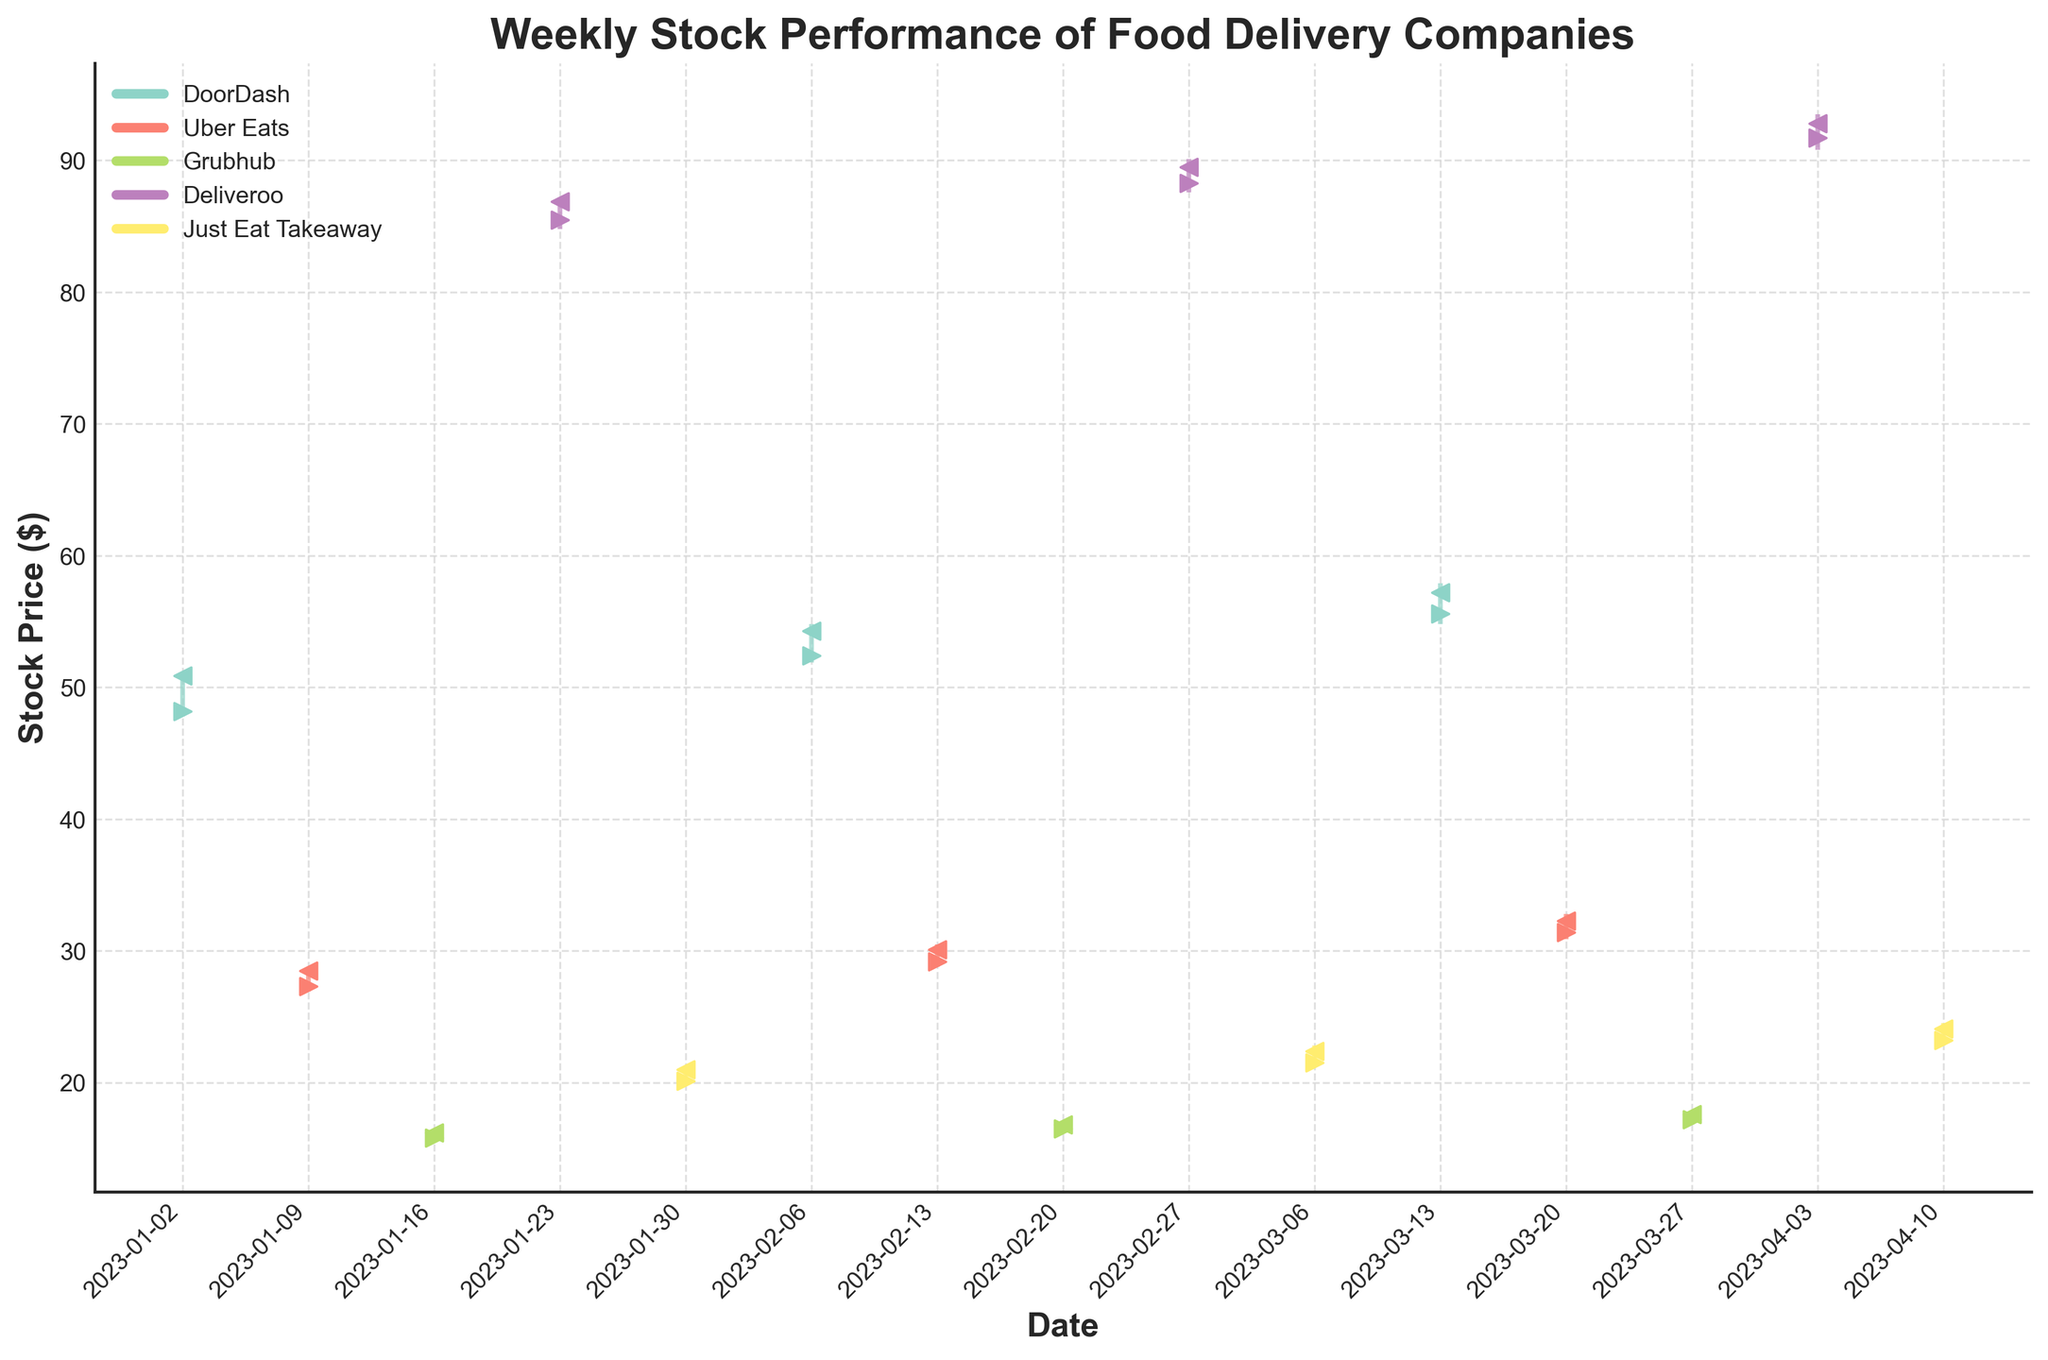What's the title of the figure? The title is typically located at the top of the figure and it describes the overall content of the chart. Here, the title reads "Weekly Stock Performance of Food Delivery Companies".
Answer: Weekly Stock Performance of Food Delivery Companies What do the markers '>' and '<' represent in the figure? The markers '>' and '<' on the chart commonly represent the opening and closing prices respectively. Observing the data points, you can see that the '>' markers correspond to Open prices and '<' markers correspond to Close prices.
Answer: '>' marks the Open price and '<' marks the Close price Which company has the highest stock price in the given weeks? To answer this, we need to look at the vertical lines representing the highs of each week. The company with the highest point overall is Deliveroo, specifically in the week starting 2023-04-03.
Answer: Deliveroo During which date did DoorDash have its highest closing price? Checking the '<' markers for DoorDash, the week starting on 2023-03-13 shows the highest closing price at 57.20.
Answer: 2023-03-13 What's the average closing price of Uber Eats for the given weeks? First, sum all closing prices for Uber Eats: 28.50 + 30.10 + 32.30 = 90.90. Then divide by the number of weeks (3): 90.90/3 = 30.30.
Answer: 30.30 How did Grubhub's stock price trend over the weeks? Observe Grubhub's '<' markers, which represent the closing prices. Grubhub's stock showed a gradual increase from 16.20 on 2023-01-16 to 17.60 on 2023-03-27.
Answer: Increasing Which two companies had the most similar high prices in the week of 2023-02-06? In that week, analyze the vertical lines representing the high prices. DoorDash (54.80) and Uber Eats (30.50) are the two companies with the high prices closest in value, both being higher relative to their standard values.
Answer: DoorDash and Uber Eats Compare the stock performance of Just Eat Takeaway on 2023-01-30 and 2023-04-10. For comparison, look at both the high and low prices, along with the open and close prices on these dates. On 2023-01-30 the open price was 20.10, the high price was 21.30, the low price was 19.80, and the close price was 21.00. On 2023-04-10 the open price was 23.20, the high price was 24.50, the low price was 22.80, and the close price was 24.10. Clearly, the performance was better in the later date with higher prices overall.
Answer: Better performance on 2023-04-10 What is the range of high stock prices for Deliveroo throughout the period? To find this range, identify the highest of the high prices and the lowest of the high prices for Deliveroo. The highest is 93.50 and the lowest is 87.20. The range is 93.50 - 87.20 = 6.30.
Answer: 6.30 